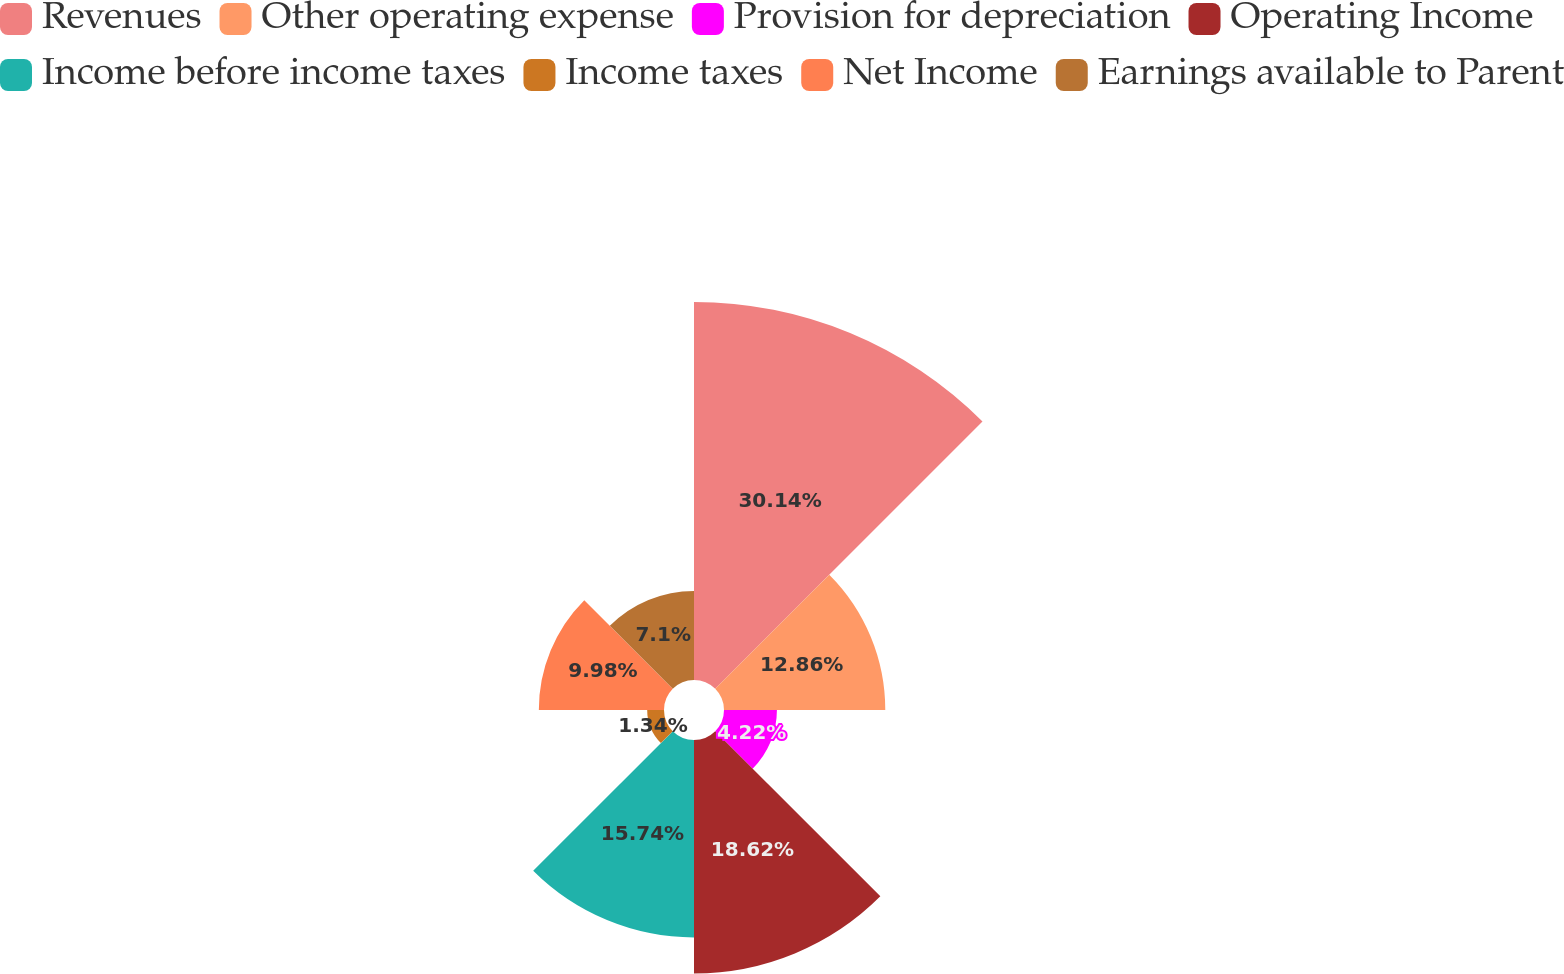<chart> <loc_0><loc_0><loc_500><loc_500><pie_chart><fcel>Revenues<fcel>Other operating expense<fcel>Provision for depreciation<fcel>Operating Income<fcel>Income before income taxes<fcel>Income taxes<fcel>Net Income<fcel>Earnings available to Parent<nl><fcel>30.14%<fcel>12.86%<fcel>4.22%<fcel>18.62%<fcel>15.74%<fcel>1.34%<fcel>9.98%<fcel>7.1%<nl></chart> 